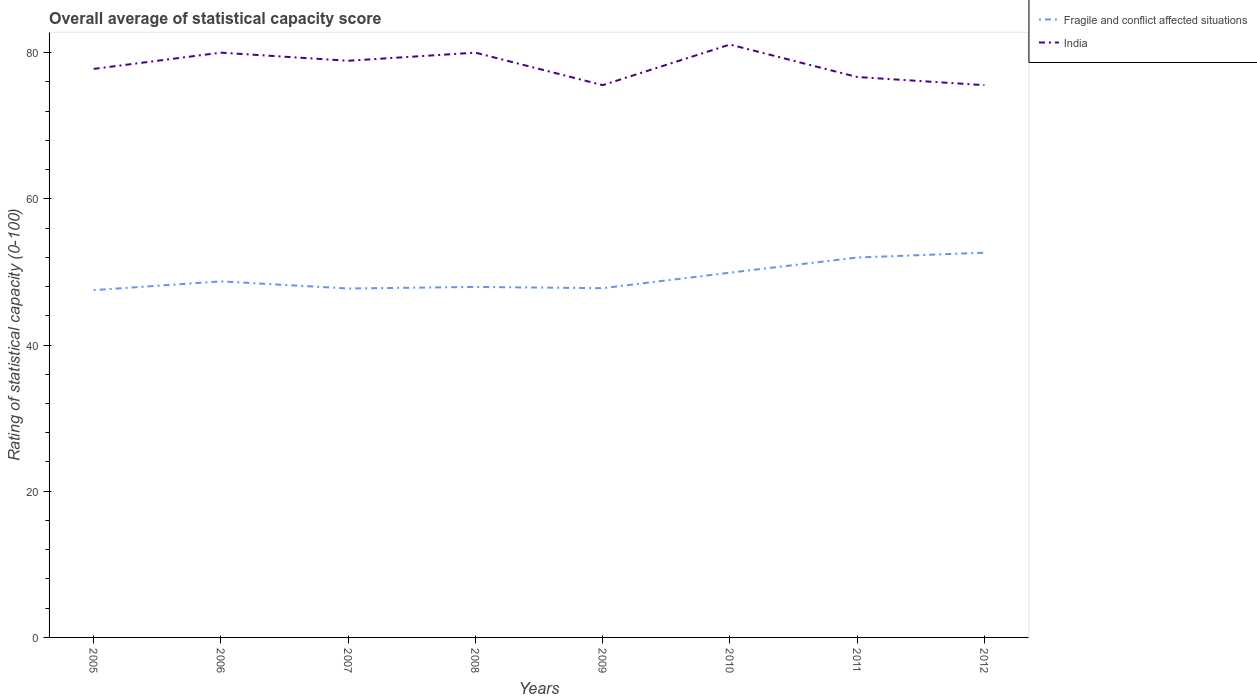How many different coloured lines are there?
Offer a terse response. 2. Does the line corresponding to Fragile and conflict affected situations intersect with the line corresponding to India?
Provide a succinct answer. No. Is the number of lines equal to the number of legend labels?
Offer a very short reply. Yes. Across all years, what is the maximum rating of statistical capacity in Fragile and conflict affected situations?
Offer a terse response. 47.51. What is the total rating of statistical capacity in India in the graph?
Give a very brief answer. 2.22. What is the difference between the highest and the second highest rating of statistical capacity in Fragile and conflict affected situations?
Your answer should be compact. 5.12. Is the rating of statistical capacity in India strictly greater than the rating of statistical capacity in Fragile and conflict affected situations over the years?
Give a very brief answer. No. How many lines are there?
Your response must be concise. 2. Does the graph contain any zero values?
Make the answer very short. No. Does the graph contain grids?
Provide a short and direct response. No. How many legend labels are there?
Provide a short and direct response. 2. How are the legend labels stacked?
Ensure brevity in your answer.  Vertical. What is the title of the graph?
Your answer should be very brief. Overall average of statistical capacity score. Does "American Samoa" appear as one of the legend labels in the graph?
Ensure brevity in your answer.  No. What is the label or title of the X-axis?
Your answer should be very brief. Years. What is the label or title of the Y-axis?
Ensure brevity in your answer.  Rating of statistical capacity (0-100). What is the Rating of statistical capacity (0-100) of Fragile and conflict affected situations in 2005?
Give a very brief answer. 47.51. What is the Rating of statistical capacity (0-100) in India in 2005?
Make the answer very short. 77.78. What is the Rating of statistical capacity (0-100) of Fragile and conflict affected situations in 2006?
Ensure brevity in your answer.  48.71. What is the Rating of statistical capacity (0-100) of Fragile and conflict affected situations in 2007?
Your response must be concise. 47.74. What is the Rating of statistical capacity (0-100) of India in 2007?
Offer a terse response. 78.89. What is the Rating of statistical capacity (0-100) of Fragile and conflict affected situations in 2008?
Make the answer very short. 47.95. What is the Rating of statistical capacity (0-100) in India in 2008?
Your answer should be very brief. 80. What is the Rating of statistical capacity (0-100) in Fragile and conflict affected situations in 2009?
Ensure brevity in your answer.  47.78. What is the Rating of statistical capacity (0-100) of India in 2009?
Your response must be concise. 75.56. What is the Rating of statistical capacity (0-100) in Fragile and conflict affected situations in 2010?
Ensure brevity in your answer.  49.9. What is the Rating of statistical capacity (0-100) of India in 2010?
Make the answer very short. 81.11. What is the Rating of statistical capacity (0-100) of Fragile and conflict affected situations in 2011?
Give a very brief answer. 51.98. What is the Rating of statistical capacity (0-100) of India in 2011?
Provide a succinct answer. 76.67. What is the Rating of statistical capacity (0-100) of Fragile and conflict affected situations in 2012?
Ensure brevity in your answer.  52.63. What is the Rating of statistical capacity (0-100) in India in 2012?
Offer a very short reply. 75.56. Across all years, what is the maximum Rating of statistical capacity (0-100) in Fragile and conflict affected situations?
Ensure brevity in your answer.  52.63. Across all years, what is the maximum Rating of statistical capacity (0-100) of India?
Provide a succinct answer. 81.11. Across all years, what is the minimum Rating of statistical capacity (0-100) of Fragile and conflict affected situations?
Your answer should be very brief. 47.51. Across all years, what is the minimum Rating of statistical capacity (0-100) of India?
Keep it short and to the point. 75.56. What is the total Rating of statistical capacity (0-100) in Fragile and conflict affected situations in the graph?
Offer a very short reply. 394.19. What is the total Rating of statistical capacity (0-100) in India in the graph?
Give a very brief answer. 625.56. What is the difference between the Rating of statistical capacity (0-100) in India in 2005 and that in 2006?
Provide a short and direct response. -2.22. What is the difference between the Rating of statistical capacity (0-100) of Fragile and conflict affected situations in 2005 and that in 2007?
Your response must be concise. -0.22. What is the difference between the Rating of statistical capacity (0-100) in India in 2005 and that in 2007?
Ensure brevity in your answer.  -1.11. What is the difference between the Rating of statistical capacity (0-100) of Fragile and conflict affected situations in 2005 and that in 2008?
Provide a succinct answer. -0.44. What is the difference between the Rating of statistical capacity (0-100) of India in 2005 and that in 2008?
Keep it short and to the point. -2.22. What is the difference between the Rating of statistical capacity (0-100) of Fragile and conflict affected situations in 2005 and that in 2009?
Offer a very short reply. -0.27. What is the difference between the Rating of statistical capacity (0-100) in India in 2005 and that in 2009?
Provide a succinct answer. 2.22. What is the difference between the Rating of statistical capacity (0-100) of Fragile and conflict affected situations in 2005 and that in 2010?
Your response must be concise. -2.39. What is the difference between the Rating of statistical capacity (0-100) in India in 2005 and that in 2010?
Give a very brief answer. -3.33. What is the difference between the Rating of statistical capacity (0-100) in Fragile and conflict affected situations in 2005 and that in 2011?
Offer a terse response. -4.46. What is the difference between the Rating of statistical capacity (0-100) of Fragile and conflict affected situations in 2005 and that in 2012?
Your answer should be very brief. -5.12. What is the difference between the Rating of statistical capacity (0-100) of India in 2005 and that in 2012?
Your answer should be compact. 2.22. What is the difference between the Rating of statistical capacity (0-100) in Fragile and conflict affected situations in 2006 and that in 2007?
Keep it short and to the point. 0.98. What is the difference between the Rating of statistical capacity (0-100) in Fragile and conflict affected situations in 2006 and that in 2008?
Ensure brevity in your answer.  0.76. What is the difference between the Rating of statistical capacity (0-100) of India in 2006 and that in 2008?
Your answer should be very brief. 0. What is the difference between the Rating of statistical capacity (0-100) in Fragile and conflict affected situations in 2006 and that in 2009?
Your answer should be very brief. 0.93. What is the difference between the Rating of statistical capacity (0-100) in India in 2006 and that in 2009?
Offer a terse response. 4.44. What is the difference between the Rating of statistical capacity (0-100) in Fragile and conflict affected situations in 2006 and that in 2010?
Provide a succinct answer. -1.19. What is the difference between the Rating of statistical capacity (0-100) of India in 2006 and that in 2010?
Ensure brevity in your answer.  -1.11. What is the difference between the Rating of statistical capacity (0-100) in Fragile and conflict affected situations in 2006 and that in 2011?
Your response must be concise. -3.26. What is the difference between the Rating of statistical capacity (0-100) in India in 2006 and that in 2011?
Provide a short and direct response. 3.33. What is the difference between the Rating of statistical capacity (0-100) in Fragile and conflict affected situations in 2006 and that in 2012?
Offer a terse response. -3.92. What is the difference between the Rating of statistical capacity (0-100) of India in 2006 and that in 2012?
Your answer should be compact. 4.44. What is the difference between the Rating of statistical capacity (0-100) of Fragile and conflict affected situations in 2007 and that in 2008?
Keep it short and to the point. -0.21. What is the difference between the Rating of statistical capacity (0-100) in India in 2007 and that in 2008?
Make the answer very short. -1.11. What is the difference between the Rating of statistical capacity (0-100) of Fragile and conflict affected situations in 2007 and that in 2009?
Your response must be concise. -0.04. What is the difference between the Rating of statistical capacity (0-100) in India in 2007 and that in 2009?
Keep it short and to the point. 3.33. What is the difference between the Rating of statistical capacity (0-100) of Fragile and conflict affected situations in 2007 and that in 2010?
Offer a terse response. -2.16. What is the difference between the Rating of statistical capacity (0-100) in India in 2007 and that in 2010?
Your answer should be very brief. -2.22. What is the difference between the Rating of statistical capacity (0-100) in Fragile and conflict affected situations in 2007 and that in 2011?
Make the answer very short. -4.24. What is the difference between the Rating of statistical capacity (0-100) in India in 2007 and that in 2011?
Keep it short and to the point. 2.22. What is the difference between the Rating of statistical capacity (0-100) of Fragile and conflict affected situations in 2007 and that in 2012?
Ensure brevity in your answer.  -4.9. What is the difference between the Rating of statistical capacity (0-100) of Fragile and conflict affected situations in 2008 and that in 2009?
Offer a terse response. 0.17. What is the difference between the Rating of statistical capacity (0-100) in India in 2008 and that in 2009?
Your answer should be very brief. 4.44. What is the difference between the Rating of statistical capacity (0-100) in Fragile and conflict affected situations in 2008 and that in 2010?
Provide a short and direct response. -1.95. What is the difference between the Rating of statistical capacity (0-100) of India in 2008 and that in 2010?
Your answer should be very brief. -1.11. What is the difference between the Rating of statistical capacity (0-100) of Fragile and conflict affected situations in 2008 and that in 2011?
Offer a very short reply. -4.03. What is the difference between the Rating of statistical capacity (0-100) of Fragile and conflict affected situations in 2008 and that in 2012?
Ensure brevity in your answer.  -4.68. What is the difference between the Rating of statistical capacity (0-100) in India in 2008 and that in 2012?
Provide a short and direct response. 4.44. What is the difference between the Rating of statistical capacity (0-100) in Fragile and conflict affected situations in 2009 and that in 2010?
Ensure brevity in your answer.  -2.12. What is the difference between the Rating of statistical capacity (0-100) in India in 2009 and that in 2010?
Provide a succinct answer. -5.56. What is the difference between the Rating of statistical capacity (0-100) in Fragile and conflict affected situations in 2009 and that in 2011?
Make the answer very short. -4.2. What is the difference between the Rating of statistical capacity (0-100) of India in 2009 and that in 2011?
Provide a short and direct response. -1.11. What is the difference between the Rating of statistical capacity (0-100) of Fragile and conflict affected situations in 2009 and that in 2012?
Your answer should be compact. -4.86. What is the difference between the Rating of statistical capacity (0-100) of Fragile and conflict affected situations in 2010 and that in 2011?
Ensure brevity in your answer.  -2.08. What is the difference between the Rating of statistical capacity (0-100) of India in 2010 and that in 2011?
Keep it short and to the point. 4.44. What is the difference between the Rating of statistical capacity (0-100) of Fragile and conflict affected situations in 2010 and that in 2012?
Give a very brief answer. -2.74. What is the difference between the Rating of statistical capacity (0-100) of India in 2010 and that in 2012?
Offer a very short reply. 5.56. What is the difference between the Rating of statistical capacity (0-100) in Fragile and conflict affected situations in 2011 and that in 2012?
Offer a very short reply. -0.66. What is the difference between the Rating of statistical capacity (0-100) in Fragile and conflict affected situations in 2005 and the Rating of statistical capacity (0-100) in India in 2006?
Give a very brief answer. -32.49. What is the difference between the Rating of statistical capacity (0-100) in Fragile and conflict affected situations in 2005 and the Rating of statistical capacity (0-100) in India in 2007?
Your response must be concise. -31.38. What is the difference between the Rating of statistical capacity (0-100) of Fragile and conflict affected situations in 2005 and the Rating of statistical capacity (0-100) of India in 2008?
Make the answer very short. -32.49. What is the difference between the Rating of statistical capacity (0-100) in Fragile and conflict affected situations in 2005 and the Rating of statistical capacity (0-100) in India in 2009?
Give a very brief answer. -28.04. What is the difference between the Rating of statistical capacity (0-100) of Fragile and conflict affected situations in 2005 and the Rating of statistical capacity (0-100) of India in 2010?
Ensure brevity in your answer.  -33.6. What is the difference between the Rating of statistical capacity (0-100) of Fragile and conflict affected situations in 2005 and the Rating of statistical capacity (0-100) of India in 2011?
Ensure brevity in your answer.  -29.16. What is the difference between the Rating of statistical capacity (0-100) of Fragile and conflict affected situations in 2005 and the Rating of statistical capacity (0-100) of India in 2012?
Keep it short and to the point. -28.04. What is the difference between the Rating of statistical capacity (0-100) of Fragile and conflict affected situations in 2006 and the Rating of statistical capacity (0-100) of India in 2007?
Provide a succinct answer. -30.18. What is the difference between the Rating of statistical capacity (0-100) in Fragile and conflict affected situations in 2006 and the Rating of statistical capacity (0-100) in India in 2008?
Keep it short and to the point. -31.29. What is the difference between the Rating of statistical capacity (0-100) of Fragile and conflict affected situations in 2006 and the Rating of statistical capacity (0-100) of India in 2009?
Offer a very short reply. -26.84. What is the difference between the Rating of statistical capacity (0-100) in Fragile and conflict affected situations in 2006 and the Rating of statistical capacity (0-100) in India in 2010?
Ensure brevity in your answer.  -32.4. What is the difference between the Rating of statistical capacity (0-100) of Fragile and conflict affected situations in 2006 and the Rating of statistical capacity (0-100) of India in 2011?
Your response must be concise. -27.96. What is the difference between the Rating of statistical capacity (0-100) of Fragile and conflict affected situations in 2006 and the Rating of statistical capacity (0-100) of India in 2012?
Offer a terse response. -26.84. What is the difference between the Rating of statistical capacity (0-100) of Fragile and conflict affected situations in 2007 and the Rating of statistical capacity (0-100) of India in 2008?
Ensure brevity in your answer.  -32.27. What is the difference between the Rating of statistical capacity (0-100) of Fragile and conflict affected situations in 2007 and the Rating of statistical capacity (0-100) of India in 2009?
Provide a succinct answer. -27.82. What is the difference between the Rating of statistical capacity (0-100) of Fragile and conflict affected situations in 2007 and the Rating of statistical capacity (0-100) of India in 2010?
Provide a short and direct response. -33.38. What is the difference between the Rating of statistical capacity (0-100) in Fragile and conflict affected situations in 2007 and the Rating of statistical capacity (0-100) in India in 2011?
Your response must be concise. -28.93. What is the difference between the Rating of statistical capacity (0-100) in Fragile and conflict affected situations in 2007 and the Rating of statistical capacity (0-100) in India in 2012?
Your response must be concise. -27.82. What is the difference between the Rating of statistical capacity (0-100) of Fragile and conflict affected situations in 2008 and the Rating of statistical capacity (0-100) of India in 2009?
Offer a very short reply. -27.61. What is the difference between the Rating of statistical capacity (0-100) of Fragile and conflict affected situations in 2008 and the Rating of statistical capacity (0-100) of India in 2010?
Provide a short and direct response. -33.16. What is the difference between the Rating of statistical capacity (0-100) in Fragile and conflict affected situations in 2008 and the Rating of statistical capacity (0-100) in India in 2011?
Your answer should be very brief. -28.72. What is the difference between the Rating of statistical capacity (0-100) of Fragile and conflict affected situations in 2008 and the Rating of statistical capacity (0-100) of India in 2012?
Your answer should be very brief. -27.61. What is the difference between the Rating of statistical capacity (0-100) of Fragile and conflict affected situations in 2009 and the Rating of statistical capacity (0-100) of India in 2010?
Give a very brief answer. -33.33. What is the difference between the Rating of statistical capacity (0-100) of Fragile and conflict affected situations in 2009 and the Rating of statistical capacity (0-100) of India in 2011?
Make the answer very short. -28.89. What is the difference between the Rating of statistical capacity (0-100) in Fragile and conflict affected situations in 2009 and the Rating of statistical capacity (0-100) in India in 2012?
Your answer should be compact. -27.78. What is the difference between the Rating of statistical capacity (0-100) in Fragile and conflict affected situations in 2010 and the Rating of statistical capacity (0-100) in India in 2011?
Your answer should be compact. -26.77. What is the difference between the Rating of statistical capacity (0-100) of Fragile and conflict affected situations in 2010 and the Rating of statistical capacity (0-100) of India in 2012?
Give a very brief answer. -25.66. What is the difference between the Rating of statistical capacity (0-100) of Fragile and conflict affected situations in 2011 and the Rating of statistical capacity (0-100) of India in 2012?
Ensure brevity in your answer.  -23.58. What is the average Rating of statistical capacity (0-100) in Fragile and conflict affected situations per year?
Your response must be concise. 49.27. What is the average Rating of statistical capacity (0-100) in India per year?
Ensure brevity in your answer.  78.19. In the year 2005, what is the difference between the Rating of statistical capacity (0-100) in Fragile and conflict affected situations and Rating of statistical capacity (0-100) in India?
Provide a succinct answer. -30.27. In the year 2006, what is the difference between the Rating of statistical capacity (0-100) of Fragile and conflict affected situations and Rating of statistical capacity (0-100) of India?
Offer a terse response. -31.29. In the year 2007, what is the difference between the Rating of statistical capacity (0-100) in Fragile and conflict affected situations and Rating of statistical capacity (0-100) in India?
Your answer should be very brief. -31.15. In the year 2008, what is the difference between the Rating of statistical capacity (0-100) of Fragile and conflict affected situations and Rating of statistical capacity (0-100) of India?
Your answer should be very brief. -32.05. In the year 2009, what is the difference between the Rating of statistical capacity (0-100) in Fragile and conflict affected situations and Rating of statistical capacity (0-100) in India?
Provide a short and direct response. -27.78. In the year 2010, what is the difference between the Rating of statistical capacity (0-100) in Fragile and conflict affected situations and Rating of statistical capacity (0-100) in India?
Provide a succinct answer. -31.21. In the year 2011, what is the difference between the Rating of statistical capacity (0-100) in Fragile and conflict affected situations and Rating of statistical capacity (0-100) in India?
Provide a short and direct response. -24.69. In the year 2012, what is the difference between the Rating of statistical capacity (0-100) of Fragile and conflict affected situations and Rating of statistical capacity (0-100) of India?
Offer a very short reply. -22.92. What is the ratio of the Rating of statistical capacity (0-100) of Fragile and conflict affected situations in 2005 to that in 2006?
Your response must be concise. 0.98. What is the ratio of the Rating of statistical capacity (0-100) of India in 2005 to that in 2006?
Provide a succinct answer. 0.97. What is the ratio of the Rating of statistical capacity (0-100) in Fragile and conflict affected situations in 2005 to that in 2007?
Offer a very short reply. 1. What is the ratio of the Rating of statistical capacity (0-100) in India in 2005 to that in 2007?
Make the answer very short. 0.99. What is the ratio of the Rating of statistical capacity (0-100) of Fragile and conflict affected situations in 2005 to that in 2008?
Your answer should be very brief. 0.99. What is the ratio of the Rating of statistical capacity (0-100) in India in 2005 to that in 2008?
Provide a succinct answer. 0.97. What is the ratio of the Rating of statistical capacity (0-100) of Fragile and conflict affected situations in 2005 to that in 2009?
Ensure brevity in your answer.  0.99. What is the ratio of the Rating of statistical capacity (0-100) of India in 2005 to that in 2009?
Give a very brief answer. 1.03. What is the ratio of the Rating of statistical capacity (0-100) in Fragile and conflict affected situations in 2005 to that in 2010?
Your answer should be very brief. 0.95. What is the ratio of the Rating of statistical capacity (0-100) in India in 2005 to that in 2010?
Give a very brief answer. 0.96. What is the ratio of the Rating of statistical capacity (0-100) in Fragile and conflict affected situations in 2005 to that in 2011?
Offer a very short reply. 0.91. What is the ratio of the Rating of statistical capacity (0-100) of India in 2005 to that in 2011?
Give a very brief answer. 1.01. What is the ratio of the Rating of statistical capacity (0-100) in Fragile and conflict affected situations in 2005 to that in 2012?
Your answer should be very brief. 0.9. What is the ratio of the Rating of statistical capacity (0-100) of India in 2005 to that in 2012?
Offer a very short reply. 1.03. What is the ratio of the Rating of statistical capacity (0-100) of Fragile and conflict affected situations in 2006 to that in 2007?
Offer a very short reply. 1.02. What is the ratio of the Rating of statistical capacity (0-100) of India in 2006 to that in 2007?
Provide a succinct answer. 1.01. What is the ratio of the Rating of statistical capacity (0-100) in Fragile and conflict affected situations in 2006 to that in 2008?
Ensure brevity in your answer.  1.02. What is the ratio of the Rating of statistical capacity (0-100) in India in 2006 to that in 2008?
Give a very brief answer. 1. What is the ratio of the Rating of statistical capacity (0-100) of Fragile and conflict affected situations in 2006 to that in 2009?
Offer a terse response. 1.02. What is the ratio of the Rating of statistical capacity (0-100) in India in 2006 to that in 2009?
Your response must be concise. 1.06. What is the ratio of the Rating of statistical capacity (0-100) in Fragile and conflict affected situations in 2006 to that in 2010?
Provide a succinct answer. 0.98. What is the ratio of the Rating of statistical capacity (0-100) in India in 2006 to that in 2010?
Provide a short and direct response. 0.99. What is the ratio of the Rating of statistical capacity (0-100) of Fragile and conflict affected situations in 2006 to that in 2011?
Your answer should be very brief. 0.94. What is the ratio of the Rating of statistical capacity (0-100) of India in 2006 to that in 2011?
Keep it short and to the point. 1.04. What is the ratio of the Rating of statistical capacity (0-100) of Fragile and conflict affected situations in 2006 to that in 2012?
Your answer should be compact. 0.93. What is the ratio of the Rating of statistical capacity (0-100) of India in 2006 to that in 2012?
Your answer should be very brief. 1.06. What is the ratio of the Rating of statistical capacity (0-100) in India in 2007 to that in 2008?
Your answer should be very brief. 0.99. What is the ratio of the Rating of statistical capacity (0-100) of India in 2007 to that in 2009?
Offer a terse response. 1.04. What is the ratio of the Rating of statistical capacity (0-100) of Fragile and conflict affected situations in 2007 to that in 2010?
Offer a very short reply. 0.96. What is the ratio of the Rating of statistical capacity (0-100) of India in 2007 to that in 2010?
Offer a terse response. 0.97. What is the ratio of the Rating of statistical capacity (0-100) in Fragile and conflict affected situations in 2007 to that in 2011?
Your answer should be very brief. 0.92. What is the ratio of the Rating of statistical capacity (0-100) in India in 2007 to that in 2011?
Provide a succinct answer. 1.03. What is the ratio of the Rating of statistical capacity (0-100) of Fragile and conflict affected situations in 2007 to that in 2012?
Provide a short and direct response. 0.91. What is the ratio of the Rating of statistical capacity (0-100) of India in 2007 to that in 2012?
Offer a terse response. 1.04. What is the ratio of the Rating of statistical capacity (0-100) in Fragile and conflict affected situations in 2008 to that in 2009?
Offer a very short reply. 1. What is the ratio of the Rating of statistical capacity (0-100) in India in 2008 to that in 2009?
Give a very brief answer. 1.06. What is the ratio of the Rating of statistical capacity (0-100) of Fragile and conflict affected situations in 2008 to that in 2010?
Provide a short and direct response. 0.96. What is the ratio of the Rating of statistical capacity (0-100) in India in 2008 to that in 2010?
Your answer should be compact. 0.99. What is the ratio of the Rating of statistical capacity (0-100) of Fragile and conflict affected situations in 2008 to that in 2011?
Provide a short and direct response. 0.92. What is the ratio of the Rating of statistical capacity (0-100) of India in 2008 to that in 2011?
Offer a very short reply. 1.04. What is the ratio of the Rating of statistical capacity (0-100) of Fragile and conflict affected situations in 2008 to that in 2012?
Your response must be concise. 0.91. What is the ratio of the Rating of statistical capacity (0-100) of India in 2008 to that in 2012?
Offer a very short reply. 1.06. What is the ratio of the Rating of statistical capacity (0-100) of Fragile and conflict affected situations in 2009 to that in 2010?
Provide a succinct answer. 0.96. What is the ratio of the Rating of statistical capacity (0-100) of India in 2009 to that in 2010?
Your answer should be very brief. 0.93. What is the ratio of the Rating of statistical capacity (0-100) of Fragile and conflict affected situations in 2009 to that in 2011?
Your answer should be very brief. 0.92. What is the ratio of the Rating of statistical capacity (0-100) in India in 2009 to that in 2011?
Provide a succinct answer. 0.99. What is the ratio of the Rating of statistical capacity (0-100) of Fragile and conflict affected situations in 2009 to that in 2012?
Your answer should be compact. 0.91. What is the ratio of the Rating of statistical capacity (0-100) of India in 2009 to that in 2012?
Offer a very short reply. 1. What is the ratio of the Rating of statistical capacity (0-100) of Fragile and conflict affected situations in 2010 to that in 2011?
Keep it short and to the point. 0.96. What is the ratio of the Rating of statistical capacity (0-100) in India in 2010 to that in 2011?
Your response must be concise. 1.06. What is the ratio of the Rating of statistical capacity (0-100) of Fragile and conflict affected situations in 2010 to that in 2012?
Provide a succinct answer. 0.95. What is the ratio of the Rating of statistical capacity (0-100) in India in 2010 to that in 2012?
Make the answer very short. 1.07. What is the ratio of the Rating of statistical capacity (0-100) of Fragile and conflict affected situations in 2011 to that in 2012?
Make the answer very short. 0.99. What is the ratio of the Rating of statistical capacity (0-100) of India in 2011 to that in 2012?
Your answer should be very brief. 1.01. What is the difference between the highest and the second highest Rating of statistical capacity (0-100) in Fragile and conflict affected situations?
Your answer should be compact. 0.66. What is the difference between the highest and the lowest Rating of statistical capacity (0-100) in Fragile and conflict affected situations?
Make the answer very short. 5.12. What is the difference between the highest and the lowest Rating of statistical capacity (0-100) in India?
Keep it short and to the point. 5.56. 